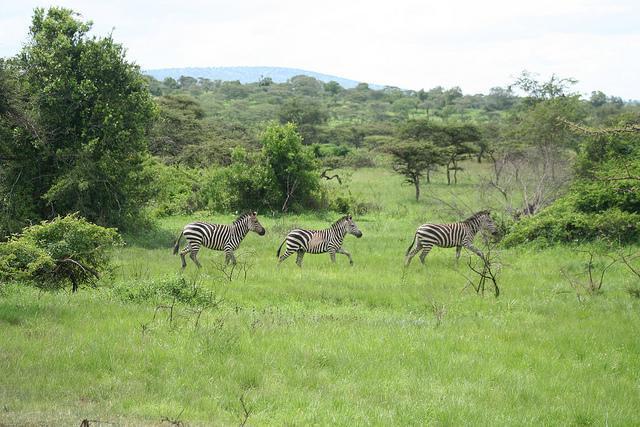How many zebras are there?
Give a very brief answer. 3. How many zebras do you see?
Give a very brief answer. 3. How many zebras are in the photo?
Give a very brief answer. 3. 